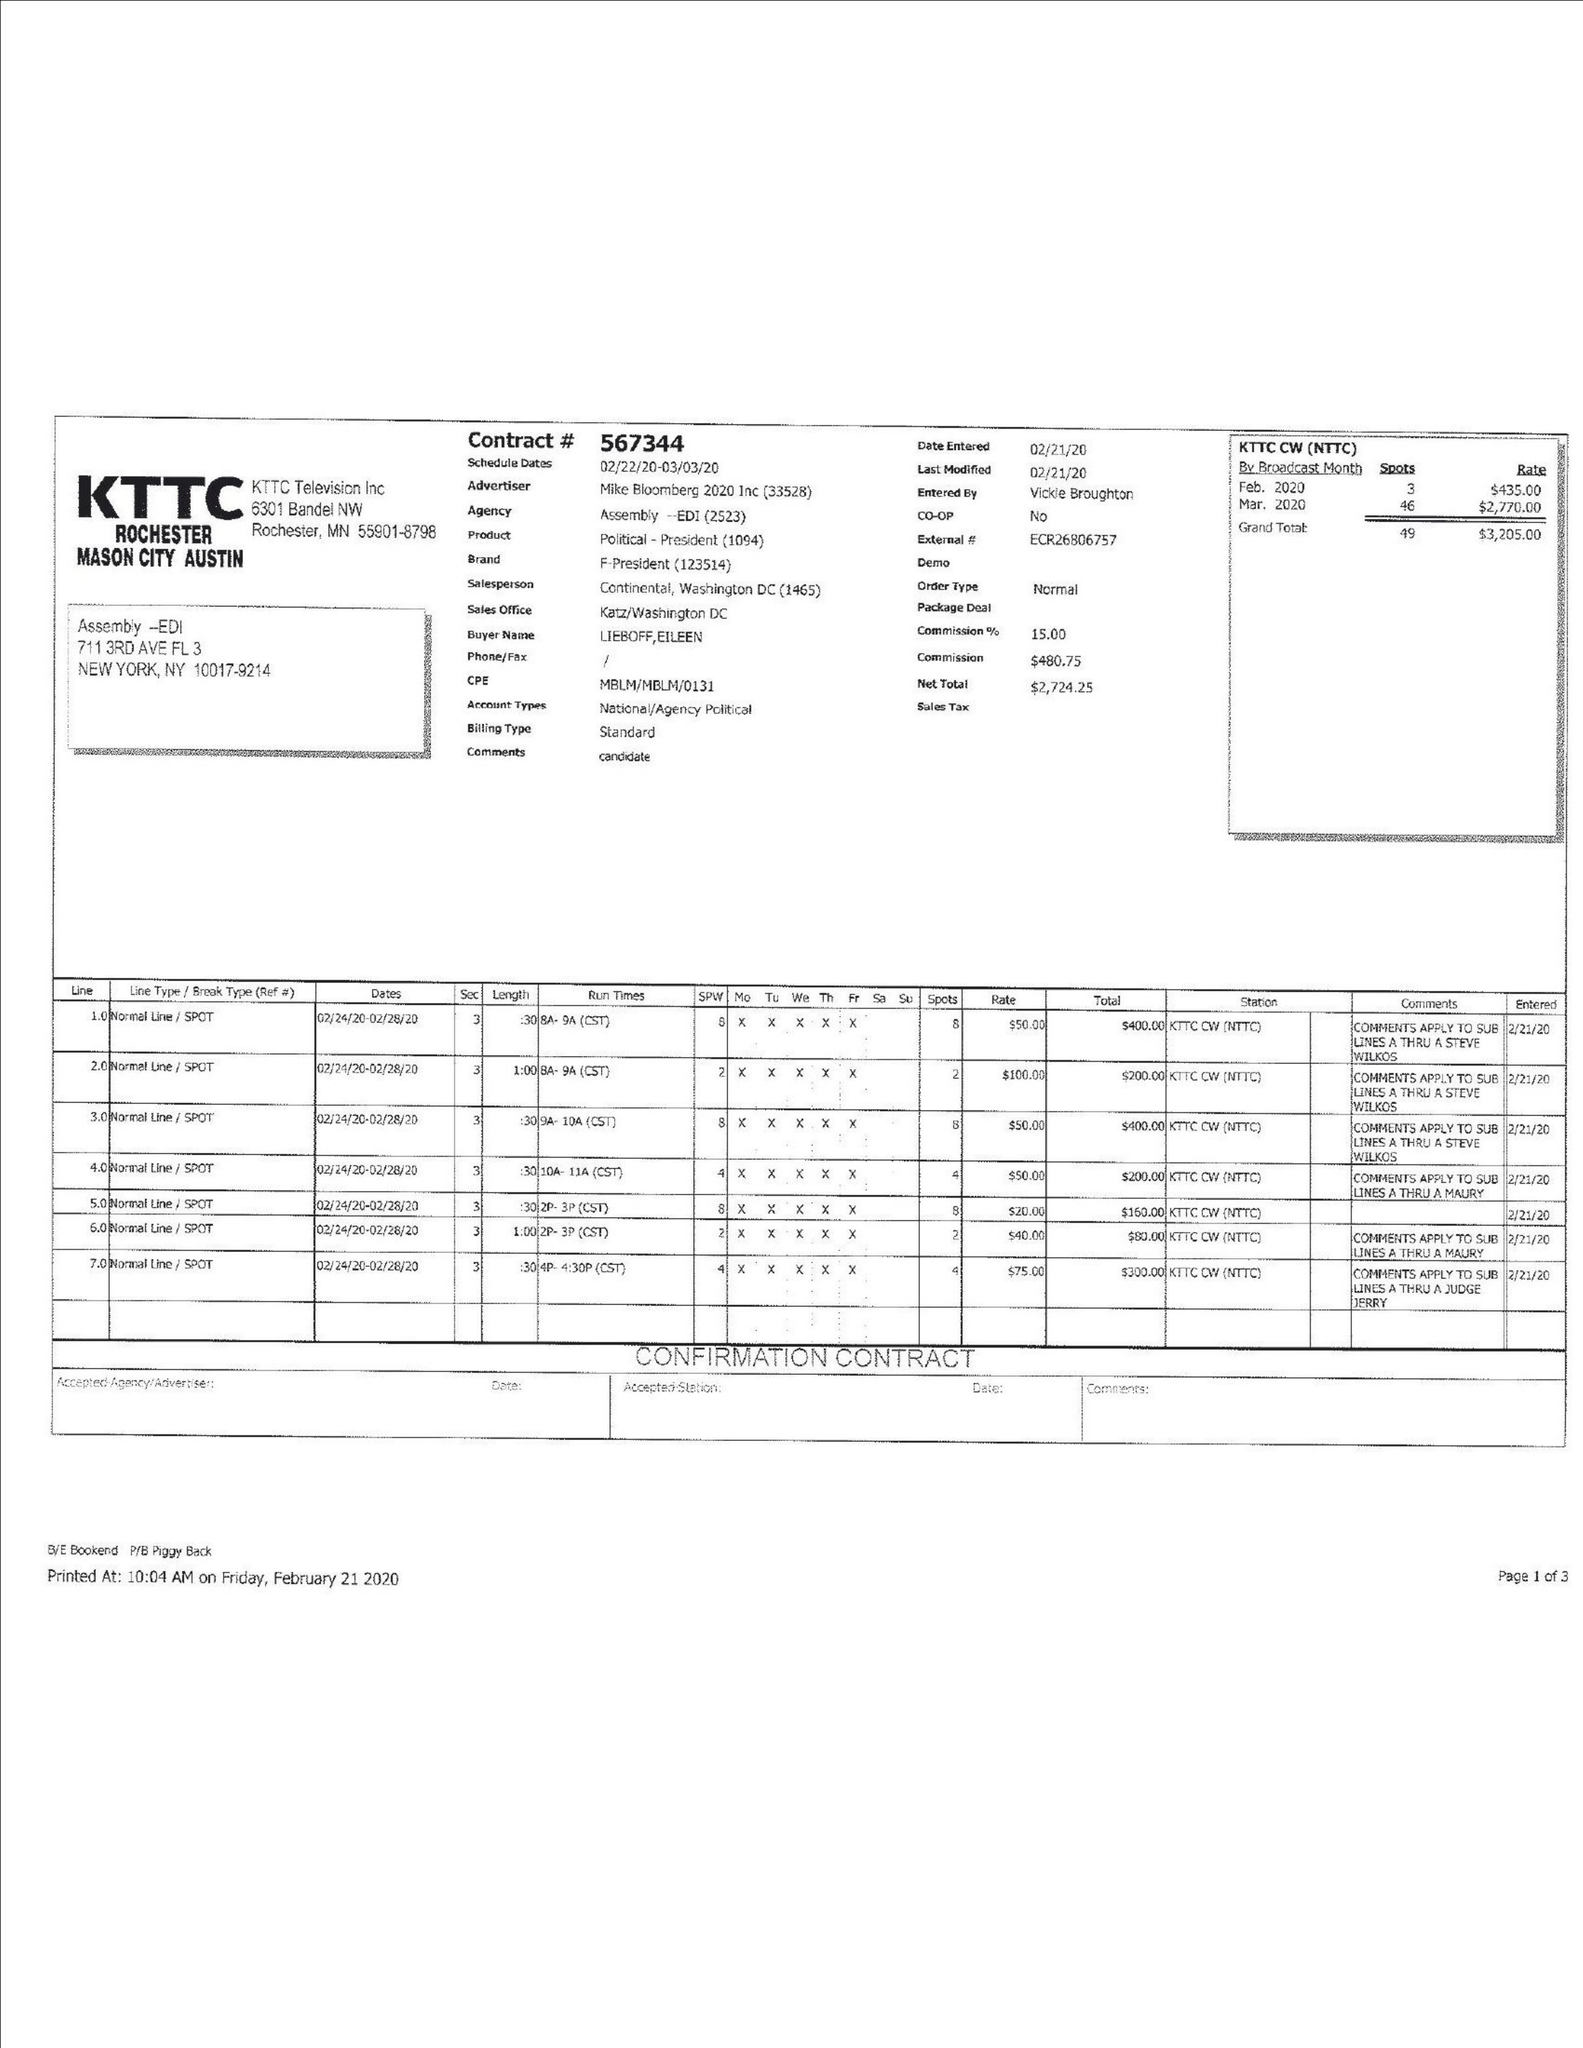What is the value for the flight_from?
Answer the question using a single word or phrase. 02/22/20 